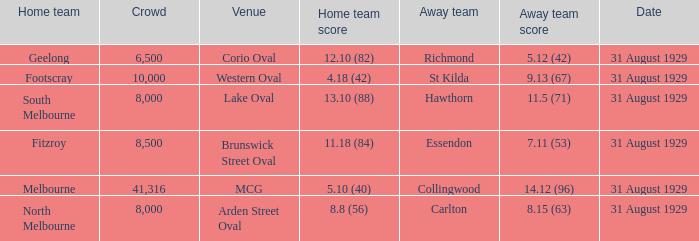Could you parse the entire table as a dict? {'header': ['Home team', 'Crowd', 'Venue', 'Home team score', 'Away team', 'Away team score', 'Date'], 'rows': [['Geelong', '6,500', 'Corio Oval', '12.10 (82)', 'Richmond', '5.12 (42)', '31 August 1929'], ['Footscray', '10,000', 'Western Oval', '4.18 (42)', 'St Kilda', '9.13 (67)', '31 August 1929'], ['South Melbourne', '8,000', 'Lake Oval', '13.10 (88)', 'Hawthorn', '11.5 (71)', '31 August 1929'], ['Fitzroy', '8,500', 'Brunswick Street Oval', '11.18 (84)', 'Essendon', '7.11 (53)', '31 August 1929'], ['Melbourne', '41,316', 'MCG', '5.10 (40)', 'Collingwood', '14.12 (96)', '31 August 1929'], ['North Melbourne', '8,000', 'Arden Street Oval', '8.8 (56)', 'Carlton', '8.15 (63)', '31 August 1929']]} What date was the game when the away team was carlton? 31 August 1929. 